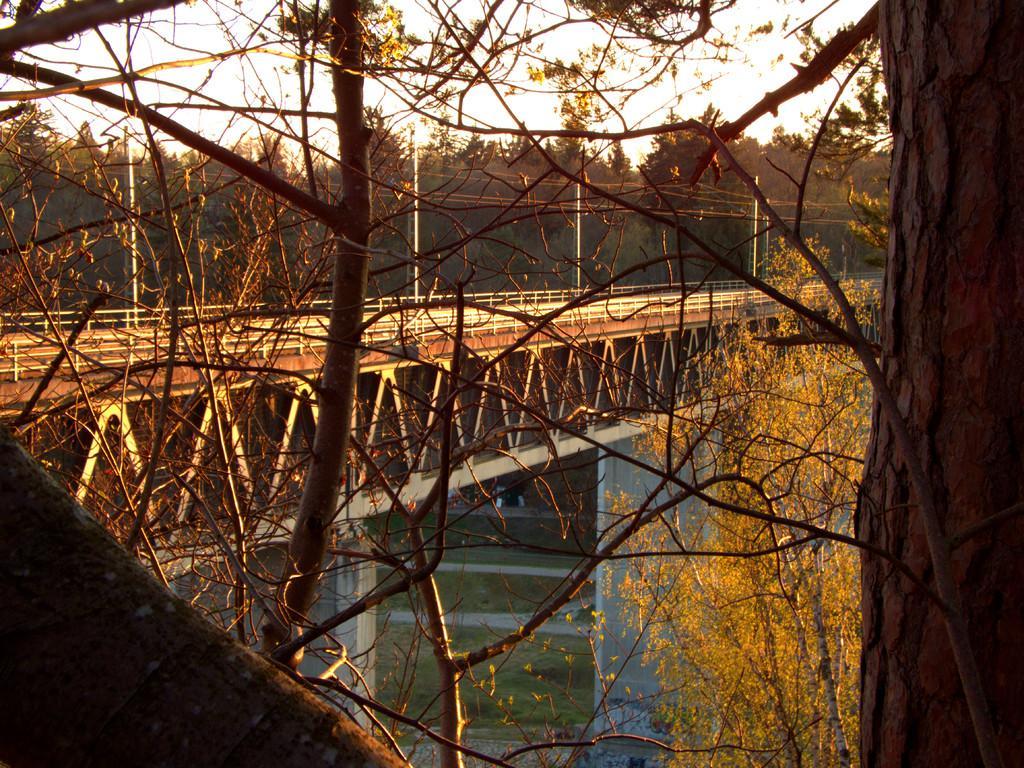In one or two sentences, can you explain what this image depicts? In this picture I can see a bridge and few poles and I can see trees, water and a cloudy sky. 